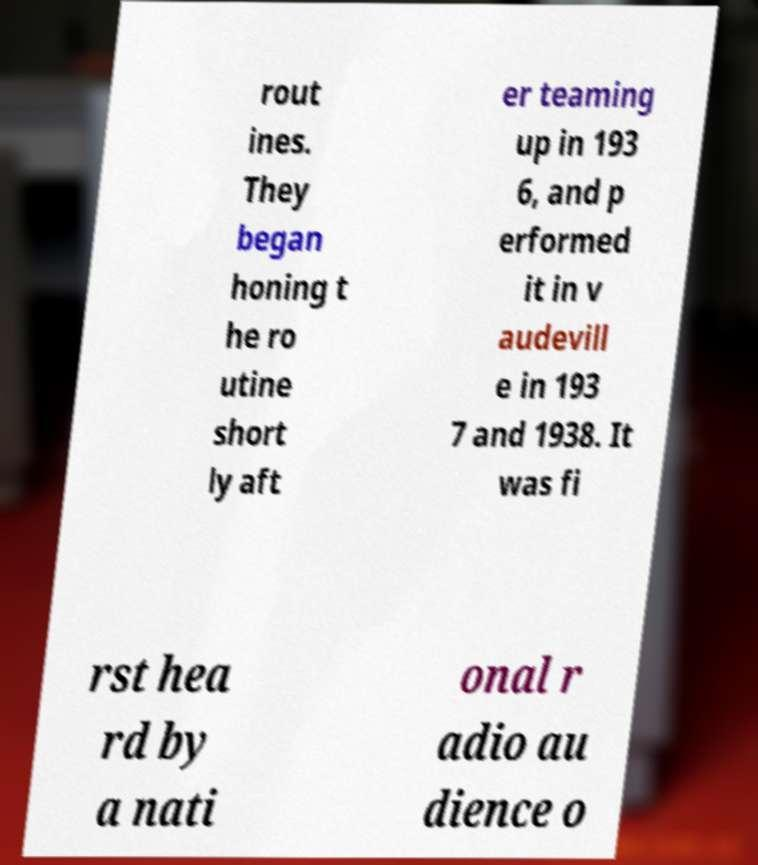Please identify and transcribe the text found in this image. rout ines. They began honing t he ro utine short ly aft er teaming up in 193 6, and p erformed it in v audevill e in 193 7 and 1938. It was fi rst hea rd by a nati onal r adio au dience o 